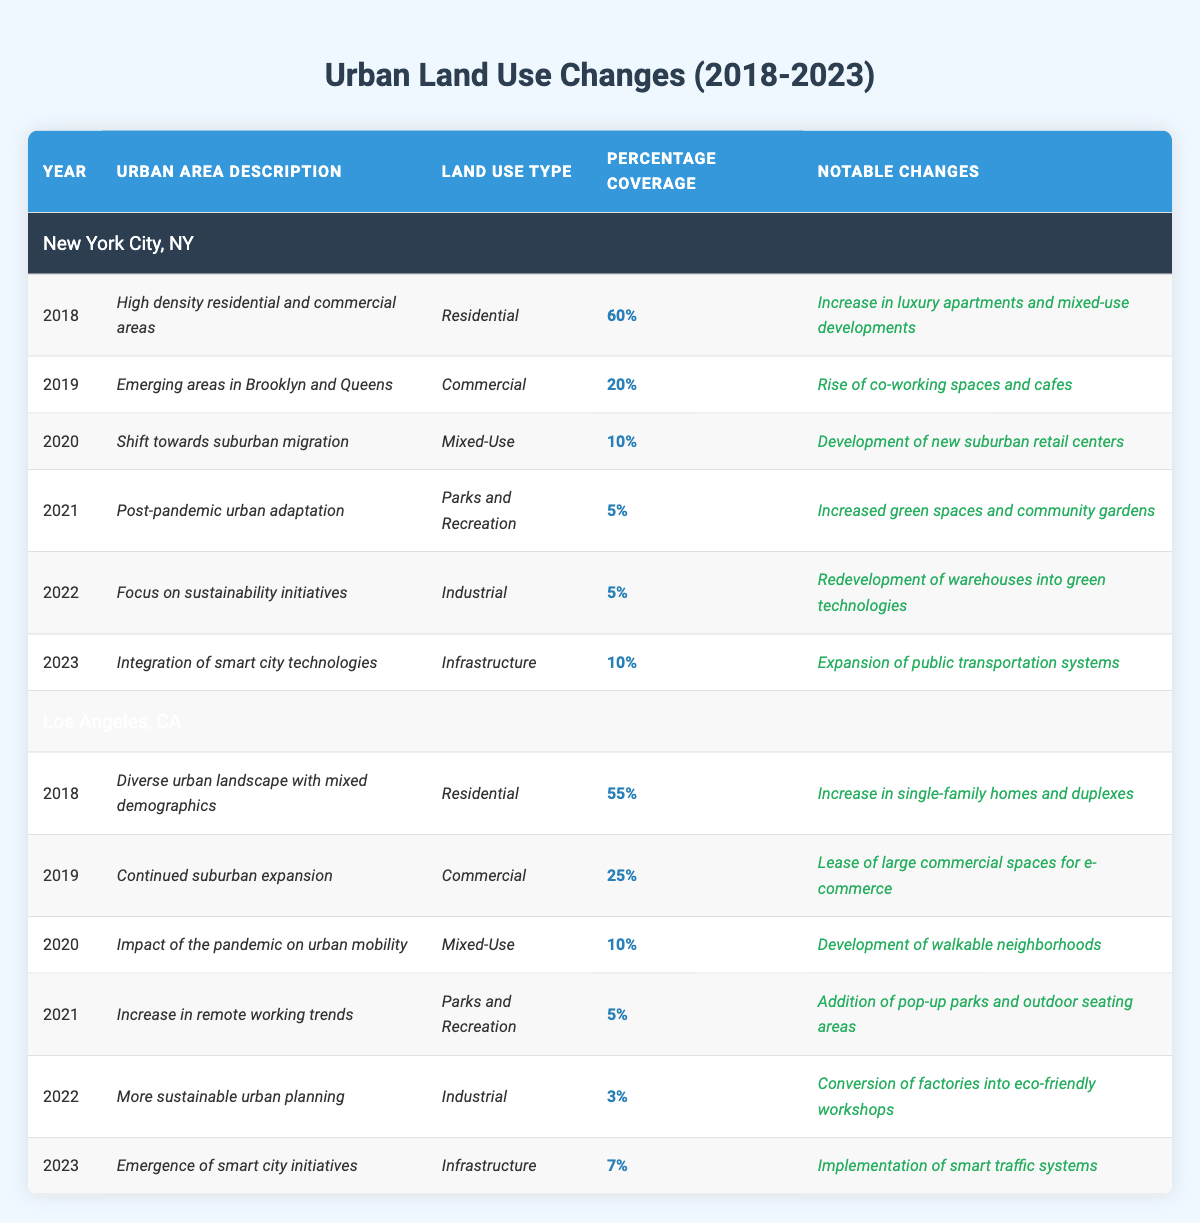What was the percentage coverage of residential land use in New York City in 2020? By looking at the table, for New York City in 2020, the land use type was described as residential, and the percentage coverage was listed as 10%.
Answer: 10% What notable change occurred in Los Angeles in 2022? In the table, for Los Angeles in 2022, the notable change was the conversion of factories into eco-friendly workshops.
Answer: Conversion of factories into eco-friendly workshops Did the percentage coverage of mixed-use land use in New York City increase from 2019 to 2023? For New York City in 2019, the percentage coverage for mixed-use was 0% (not directly listed, but only residential and commercial types were specified), while in 2023 it was 10%. Therefore, it increased.
Answer: Yes What was the total percentage coverage of parks and recreation in both cities from 2018 to 2023? Summing up the percentage coverage for parks and recreation: New York City in 2021 (5%) and Los Angeles in 2021 (5%) gives a total of 5 + 5 = 10.
Answer: 10% In which year did Los Angeles experience its lowest percentage coverage for industrial land use? Looking at the table for Los Angeles, the percentage coverage for industrial land use was 3% in 2022, which is lower than 5% in 2018 and 2021.
Answer: 2022 What overall trend can be observed in residential land use coverage in New York City from 2018 to 2023? The table shows that the residential percentage coverage started at 60% in 2018 and decreased to 10% by 2020 and remained consistent thereafter. Hence, the trend is a significant decrease in residential coverage.
Answer: Decrease Was there an increase in commercial land use in New York City from 2018 to 2023? Referring to the table, commercial land use percentage in New York City was 20% in 2019 but not listed after that year, indicating that it did not show an increase after 2019.
Answer: No What percentage of industrial land use was observed in Los Angeles in 2023 compared to the percentage in 2018? The table indicates that industrial land use was 3% in 2022 and 7% in 2023, compared to 4% in 2018, showing a rise but still less than the previous year's percentage (3% compared to 5%).
Answer: Increased from 2018 to 2023 Which city had more total notable changes related to parks and recreation from 2018 to 2023? Examining the table, notable changes for parks and recreation were present in both cities only in 2021 (5% each), therefore, there were equal changes.
Answer: They are equal What was the main focus of urban area development in New York City in 2022? The table indicates that New York City's main focus in 2022 was on sustainability initiatives, emphasizing redevelopment of warehouses into green technologies.
Answer: Sustainability initiatives Was the increase of single-family homes in Los Angeles more significant than the increase of luxury apartments in New York City from 2018 to 2019? The data shows that single-family homes increased significantly in 2018 in Los Angeles, whereas in New York City, the increase in luxury apartments was more about existing areas. Thus, both can be considered significant, but their overall measurements and impacts are not directly comparable in this table.
Answer: Not directly comparable 